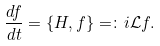<formula> <loc_0><loc_0><loc_500><loc_500>\frac { d f } { d t } = \{ H , f \} = \colon i \mathcal { L } f .</formula> 